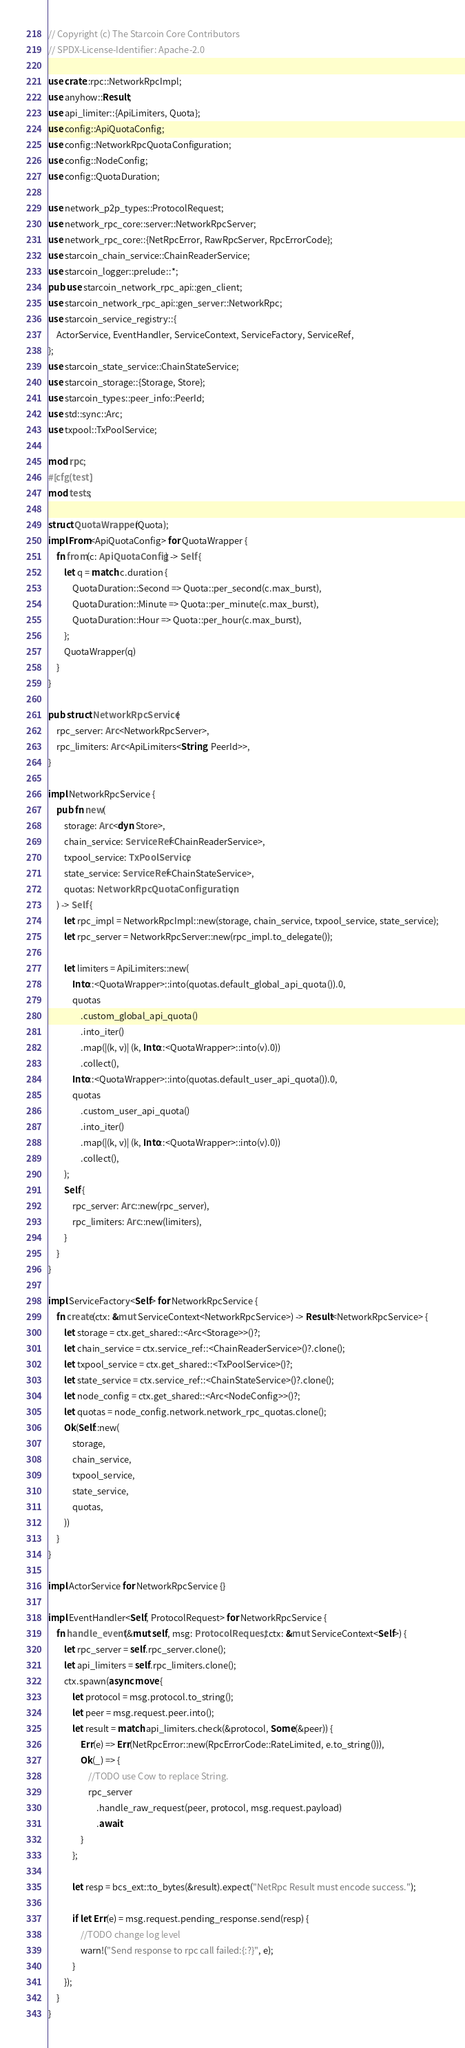<code> <loc_0><loc_0><loc_500><loc_500><_Rust_>// Copyright (c) The Starcoin Core Contributors
// SPDX-License-Identifier: Apache-2.0

use crate::rpc::NetworkRpcImpl;
use anyhow::Result;
use api_limiter::{ApiLimiters, Quota};
use config::ApiQuotaConfig;
use config::NetworkRpcQuotaConfiguration;
use config::NodeConfig;
use config::QuotaDuration;

use network_p2p_types::ProtocolRequest;
use network_rpc_core::server::NetworkRpcServer;
use network_rpc_core::{NetRpcError, RawRpcServer, RpcErrorCode};
use starcoin_chain_service::ChainReaderService;
use starcoin_logger::prelude::*;
pub use starcoin_network_rpc_api::gen_client;
use starcoin_network_rpc_api::gen_server::NetworkRpc;
use starcoin_service_registry::{
    ActorService, EventHandler, ServiceContext, ServiceFactory, ServiceRef,
};
use starcoin_state_service::ChainStateService;
use starcoin_storage::{Storage, Store};
use starcoin_types::peer_info::PeerId;
use std::sync::Arc;
use txpool::TxPoolService;

mod rpc;
#[cfg(test)]
mod tests;

struct QuotaWrapper(Quota);
impl From<ApiQuotaConfig> for QuotaWrapper {
    fn from(c: ApiQuotaConfig) -> Self {
        let q = match c.duration {
            QuotaDuration::Second => Quota::per_second(c.max_burst),
            QuotaDuration::Minute => Quota::per_minute(c.max_burst),
            QuotaDuration::Hour => Quota::per_hour(c.max_burst),
        };
        QuotaWrapper(q)
    }
}

pub struct NetworkRpcService {
    rpc_server: Arc<NetworkRpcServer>,
    rpc_limiters: Arc<ApiLimiters<String, PeerId>>,
}

impl NetworkRpcService {
    pub fn new(
        storage: Arc<dyn Store>,
        chain_service: ServiceRef<ChainReaderService>,
        txpool_service: TxPoolService,
        state_service: ServiceRef<ChainStateService>,
        quotas: NetworkRpcQuotaConfiguration,
    ) -> Self {
        let rpc_impl = NetworkRpcImpl::new(storage, chain_service, txpool_service, state_service);
        let rpc_server = NetworkRpcServer::new(rpc_impl.to_delegate());

        let limiters = ApiLimiters::new(
            Into::<QuotaWrapper>::into(quotas.default_global_api_quota()).0,
            quotas
                .custom_global_api_quota()
                .into_iter()
                .map(|(k, v)| (k, Into::<QuotaWrapper>::into(v).0))
                .collect(),
            Into::<QuotaWrapper>::into(quotas.default_user_api_quota()).0,
            quotas
                .custom_user_api_quota()
                .into_iter()
                .map(|(k, v)| (k, Into::<QuotaWrapper>::into(v).0))
                .collect(),
        );
        Self {
            rpc_server: Arc::new(rpc_server),
            rpc_limiters: Arc::new(limiters),
        }
    }
}

impl ServiceFactory<Self> for NetworkRpcService {
    fn create(ctx: &mut ServiceContext<NetworkRpcService>) -> Result<NetworkRpcService> {
        let storage = ctx.get_shared::<Arc<Storage>>()?;
        let chain_service = ctx.service_ref::<ChainReaderService>()?.clone();
        let txpool_service = ctx.get_shared::<TxPoolService>()?;
        let state_service = ctx.service_ref::<ChainStateService>()?.clone();
        let node_config = ctx.get_shared::<Arc<NodeConfig>>()?;
        let quotas = node_config.network.network_rpc_quotas.clone();
        Ok(Self::new(
            storage,
            chain_service,
            txpool_service,
            state_service,
            quotas,
        ))
    }
}

impl ActorService for NetworkRpcService {}

impl EventHandler<Self, ProtocolRequest> for NetworkRpcService {
    fn handle_event(&mut self, msg: ProtocolRequest, ctx: &mut ServiceContext<Self>) {
        let rpc_server = self.rpc_server.clone();
        let api_limiters = self.rpc_limiters.clone();
        ctx.spawn(async move {
            let protocol = msg.protocol.to_string();
            let peer = msg.request.peer.into();
            let result = match api_limiters.check(&protocol, Some(&peer)) {
                Err(e) => Err(NetRpcError::new(RpcErrorCode::RateLimited, e.to_string())),
                Ok(_) => {
                    //TODO use Cow to replace String.
                    rpc_server
                        .handle_raw_request(peer, protocol, msg.request.payload)
                        .await
                }
            };

            let resp = bcs_ext::to_bytes(&result).expect("NetRpc Result must encode success.");

            if let Err(e) = msg.request.pending_response.send(resp) {
                //TODO change log level
                warn!("Send response to rpc call failed:{:?}", e);
            }
        });
    }
}
</code> 